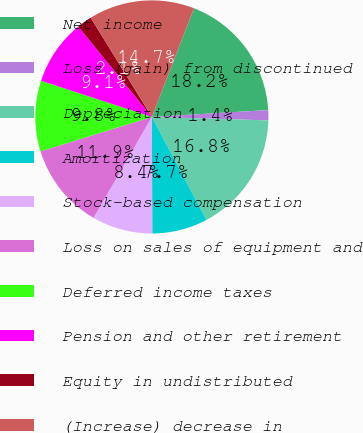<chart> <loc_0><loc_0><loc_500><loc_500><pie_chart><fcel>Net income<fcel>Loss (gain) from discontinued<fcel>Depreciation<fcel>Amortization<fcel>Stock-based compensation<fcel>Loss on sales of equipment and<fcel>Deferred income taxes<fcel>Pension and other retirement<fcel>Equity in undistributed<fcel>(Increase) decrease in<nl><fcel>18.17%<fcel>1.41%<fcel>16.78%<fcel>7.69%<fcel>8.39%<fcel>11.89%<fcel>9.79%<fcel>9.09%<fcel>2.1%<fcel>14.68%<nl></chart> 